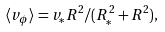<formula> <loc_0><loc_0><loc_500><loc_500>\langle v _ { \phi } \rangle = v _ { \ast } R ^ { 2 } / ( R _ { \ast } ^ { 2 } + R ^ { 2 } ) ,</formula> 